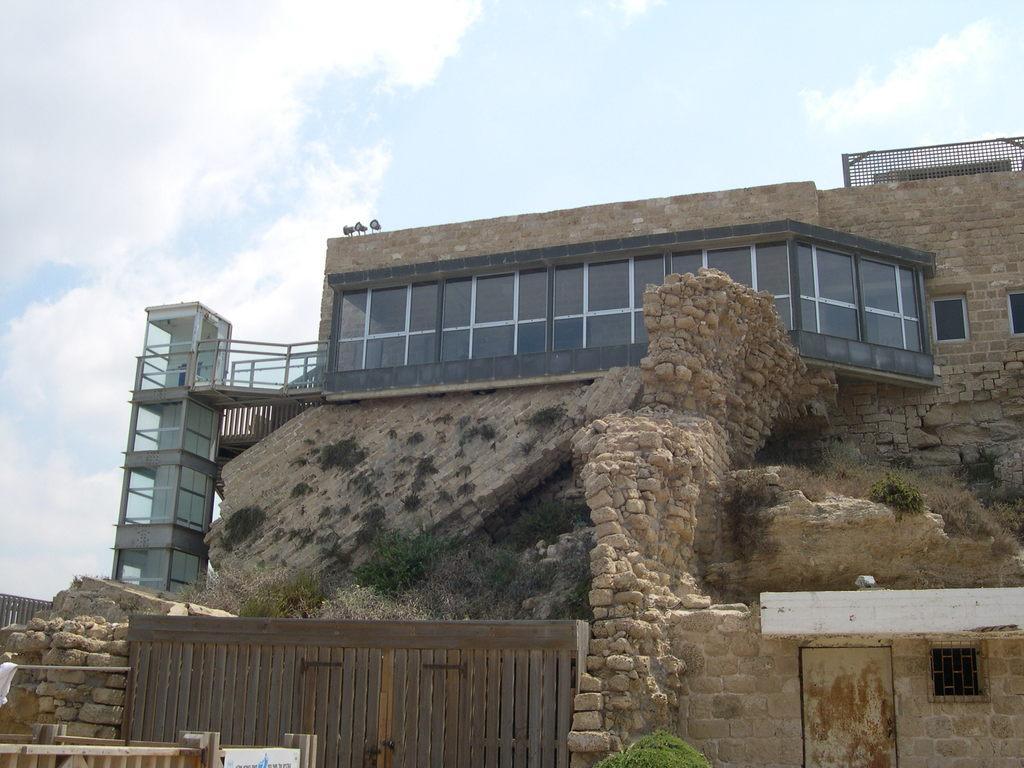Describe this image in one or two sentences. In the center of the image there is building. There is a wooden gate at the bottom of the image. There is a plant. At the top of the image there is sky and clouds. 